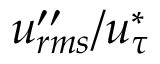<formula> <loc_0><loc_0><loc_500><loc_500>u _ { r m s } ^ { \prime \prime } / u _ { \tau } ^ { * }</formula> 